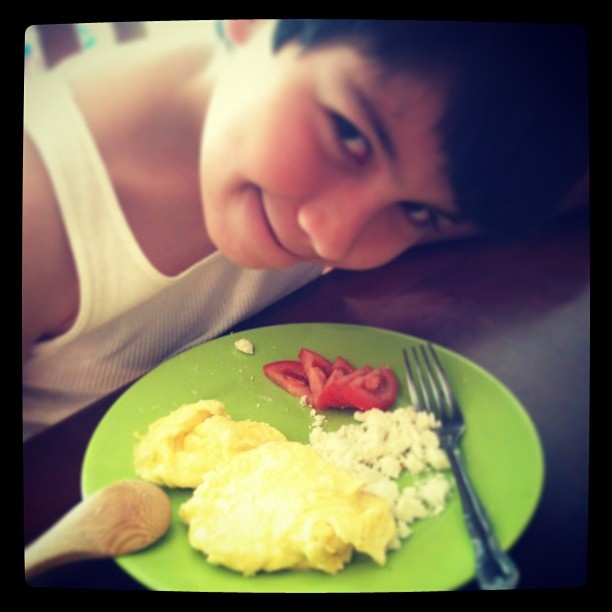Describe the objects in this image and their specific colors. I can see people in black, brown, khaki, and tan tones, dining table in black, navy, gray, and purple tones, spoon in black, tan, and khaki tones, and fork in black, gray, blue, navy, and green tones in this image. 